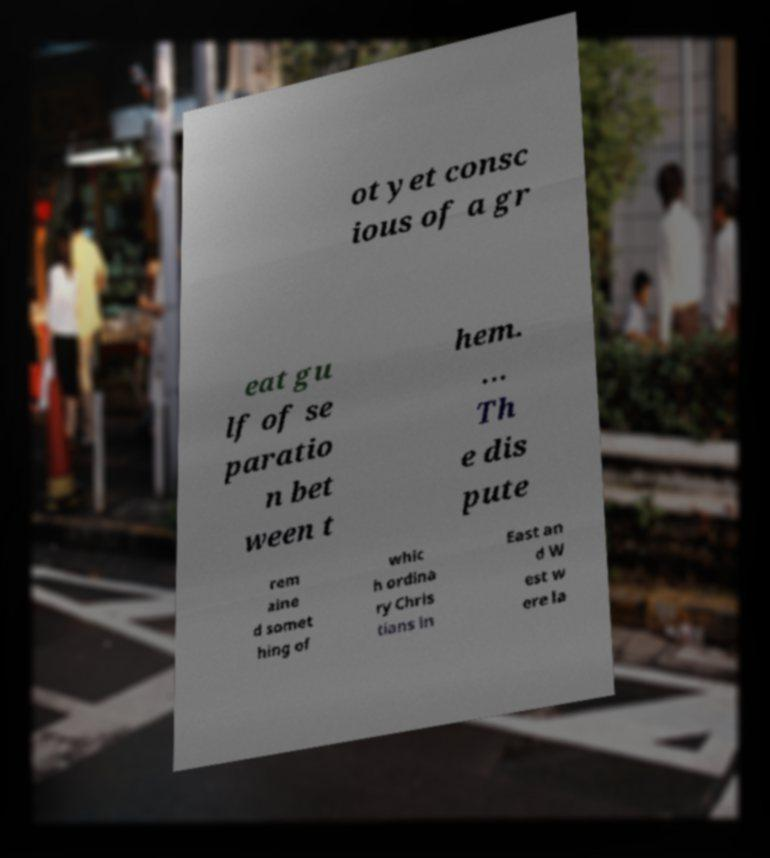Could you extract and type out the text from this image? ot yet consc ious of a gr eat gu lf of se paratio n bet ween t hem. … Th e dis pute rem aine d somet hing of whic h ordina ry Chris tians in East an d W est w ere la 